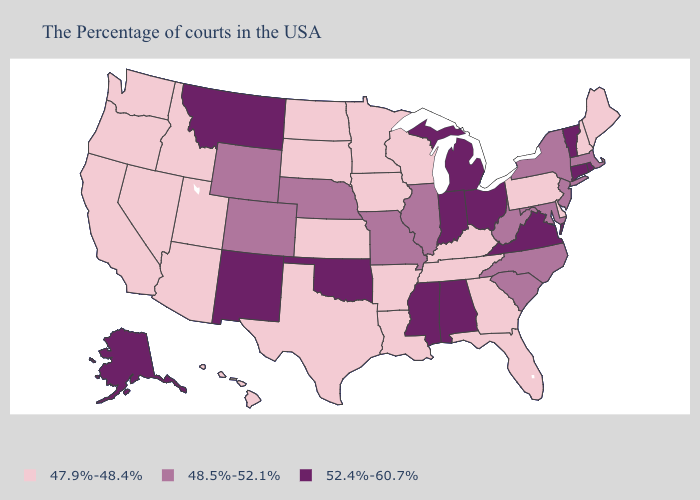Name the states that have a value in the range 52.4%-60.7%?
Be succinct. Rhode Island, Vermont, Connecticut, Virginia, Ohio, Michigan, Indiana, Alabama, Mississippi, Oklahoma, New Mexico, Montana, Alaska. Name the states that have a value in the range 52.4%-60.7%?
Short answer required. Rhode Island, Vermont, Connecticut, Virginia, Ohio, Michigan, Indiana, Alabama, Mississippi, Oklahoma, New Mexico, Montana, Alaska. Name the states that have a value in the range 48.5%-52.1%?
Short answer required. Massachusetts, New York, New Jersey, Maryland, North Carolina, South Carolina, West Virginia, Illinois, Missouri, Nebraska, Wyoming, Colorado. Name the states that have a value in the range 52.4%-60.7%?
Be succinct. Rhode Island, Vermont, Connecticut, Virginia, Ohio, Michigan, Indiana, Alabama, Mississippi, Oklahoma, New Mexico, Montana, Alaska. What is the value of Connecticut?
Keep it brief. 52.4%-60.7%. How many symbols are there in the legend?
Short answer required. 3. Name the states that have a value in the range 48.5%-52.1%?
Quick response, please. Massachusetts, New York, New Jersey, Maryland, North Carolina, South Carolina, West Virginia, Illinois, Missouri, Nebraska, Wyoming, Colorado. Name the states that have a value in the range 48.5%-52.1%?
Write a very short answer. Massachusetts, New York, New Jersey, Maryland, North Carolina, South Carolina, West Virginia, Illinois, Missouri, Nebraska, Wyoming, Colorado. What is the lowest value in the MidWest?
Give a very brief answer. 47.9%-48.4%. What is the value of Washington?
Quick response, please. 47.9%-48.4%. What is the lowest value in states that border Louisiana?
Be succinct. 47.9%-48.4%. Does Ohio have the highest value in the MidWest?
Be succinct. Yes. Name the states that have a value in the range 47.9%-48.4%?
Write a very short answer. Maine, New Hampshire, Delaware, Pennsylvania, Florida, Georgia, Kentucky, Tennessee, Wisconsin, Louisiana, Arkansas, Minnesota, Iowa, Kansas, Texas, South Dakota, North Dakota, Utah, Arizona, Idaho, Nevada, California, Washington, Oregon, Hawaii. Among the states that border Missouri , does Kansas have the lowest value?
Be succinct. Yes. Among the states that border Maine , which have the highest value?
Give a very brief answer. New Hampshire. 